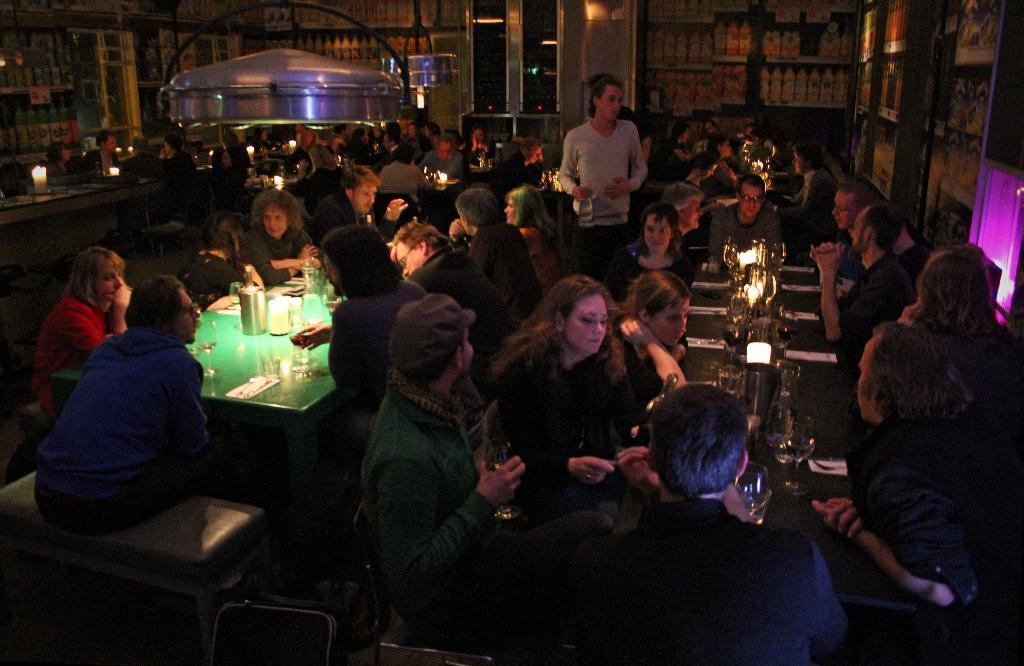Please provide a concise description of this image. There are many people sitting in the room in the chairs around the tables on which some glasses and jars were present. There are men and women in this group. There is a man standing. In the background there is a wall. 